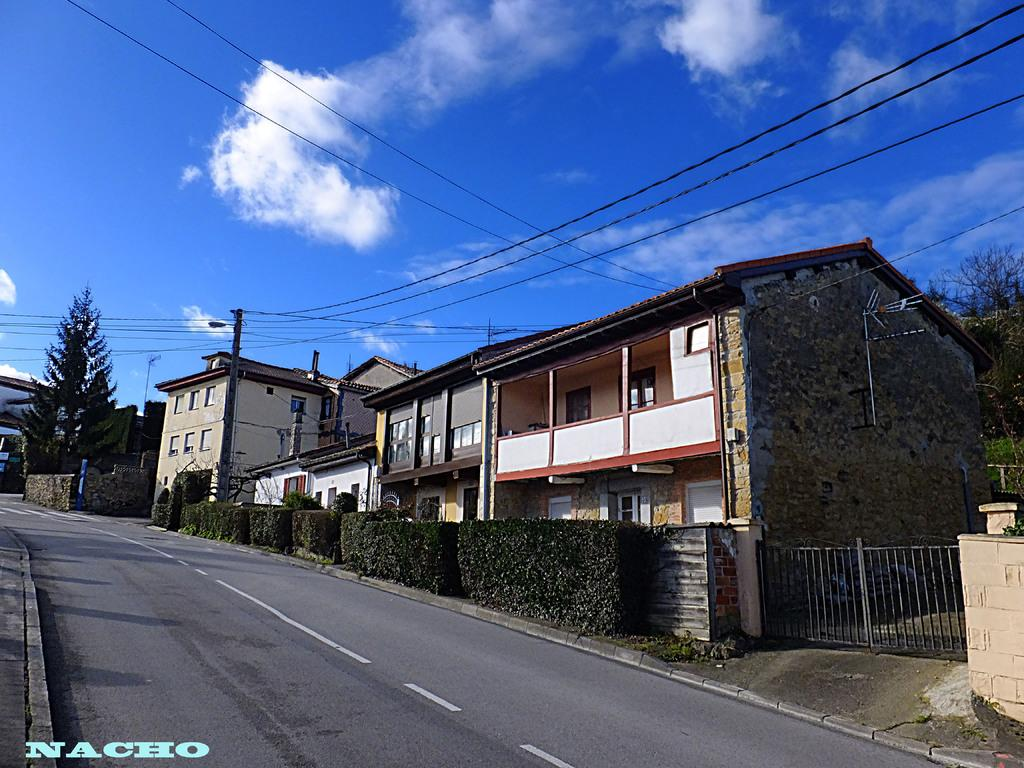<image>
Provide a brief description of the given image. The house and street photo was taken by Nacho 